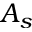Convert formula to latex. <formula><loc_0><loc_0><loc_500><loc_500>A _ { s }</formula> 